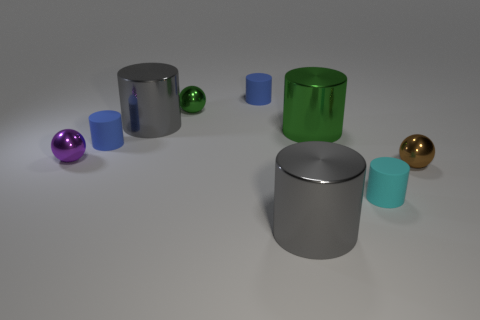What size is the ball that is both on the left side of the small cyan object and in front of the small green ball?
Offer a terse response. Small. There is a big green metallic object that is left of the small brown metal ball on the right side of the tiny green ball; how many purple metal objects are behind it?
Provide a short and direct response. 0. What number of large things are either metallic cylinders or blue matte things?
Keep it short and to the point. 3. Are the gray thing that is in front of the big green metallic cylinder and the tiny purple ball made of the same material?
Keep it short and to the point. Yes. There is a blue thing that is in front of the gray cylinder behind the large gray thing in front of the brown metallic thing; what is its material?
Provide a short and direct response. Rubber. What number of matte objects are either large brown things or brown spheres?
Give a very brief answer. 0. Is there a big red ball?
Make the answer very short. No. There is a large metallic thing that is on the right side of the gray shiny cylinder that is in front of the big green metal object; what color is it?
Keep it short and to the point. Green. What number of things are tiny metallic things or small metallic spheres behind the purple sphere?
Ensure brevity in your answer.  3. There is a tiny matte object that is in front of the small purple metallic object; what is its color?
Ensure brevity in your answer.  Cyan. 